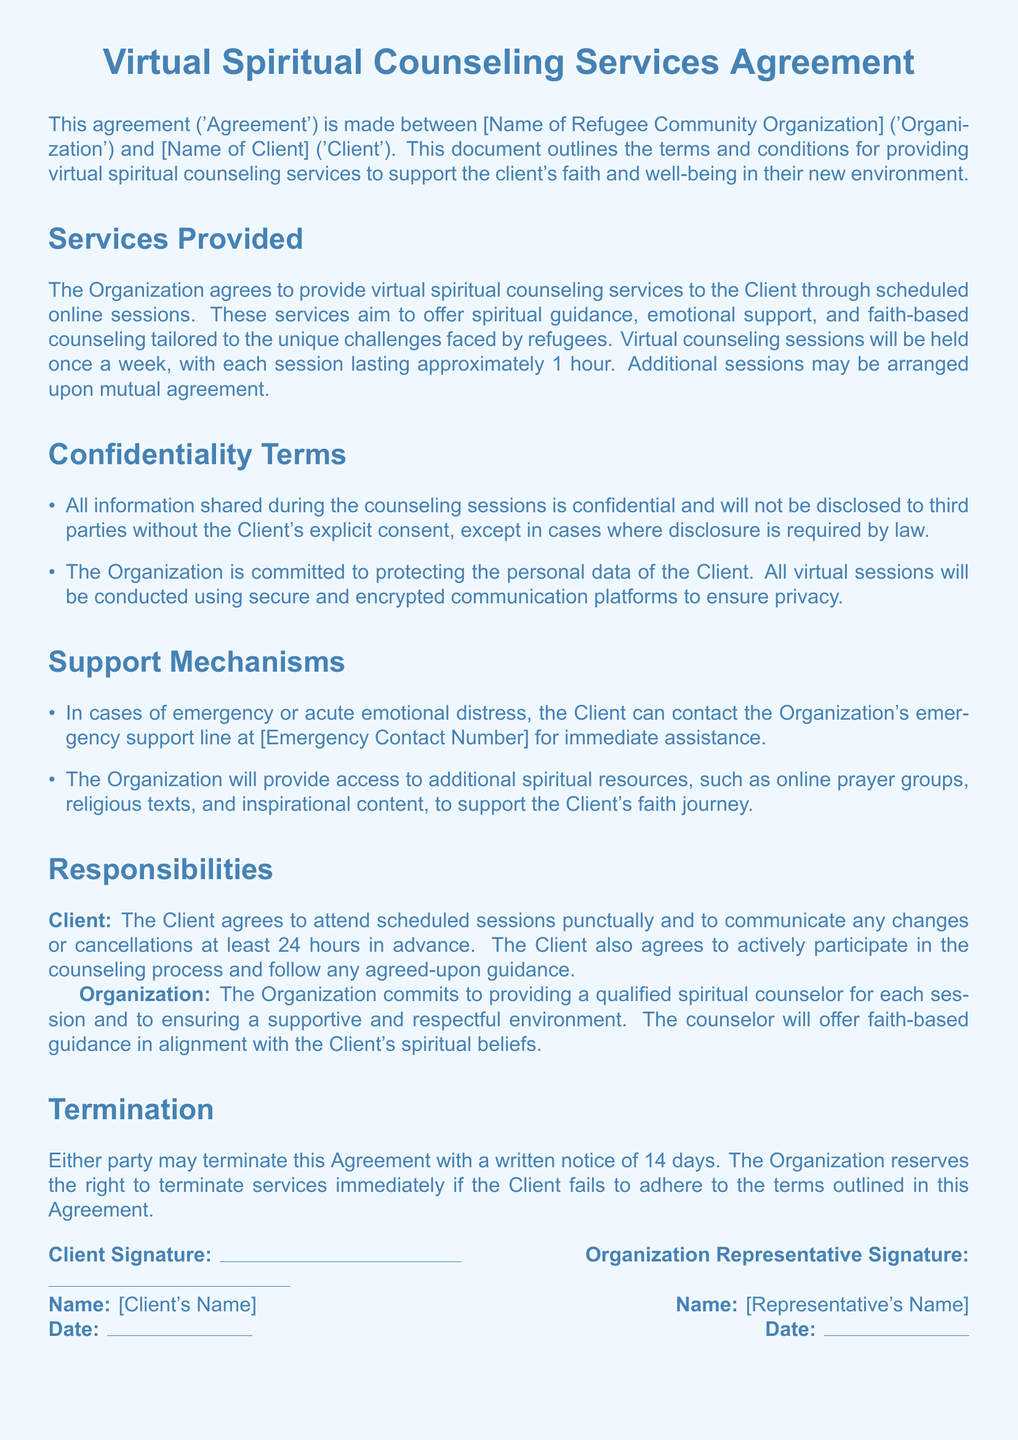What services are provided? The services consist of virtual spiritual counseling, emotional support, and faith-based counseling tailored to refugees.
Answer: Virtual spiritual counseling services How often will the sessions be held? The document specifies that sessions will be held once a week.
Answer: Once a week What is the duration of each session? Each counseling session lasts approximately 1 hour, as mentioned in the document.
Answer: 1 hour What must the Client do if they need to cancel a session? The Client must communicate any changes or cancellations at least 24 hours in advance.
Answer: 24 hours in advance What kind of support is available in case of emergency? The Client can contact the Organization's emergency support line for immediate assistance.
Answer: Emergency support line What is the confidentiality rule for information shared in the sessions? Information shared is confidential and will not be disclosed without the Client's consent, except by law.
Answer: Confidentiality How does the Organization ensure the security of virtual sessions? The Organization conducts sessions using secure and encrypted communication platforms.
Answer: Secure and encrypted communication platforms What rights does the Organization reserve regarding the termination of services? The Organization reserves the right to terminate services immediately if the Client fails to adhere to the terms outlined.
Answer: Terminate services immediately What is the notice period for termination of this Agreement? Either party may terminate the Agreement with a written notice of 14 days.
Answer: 14 days 